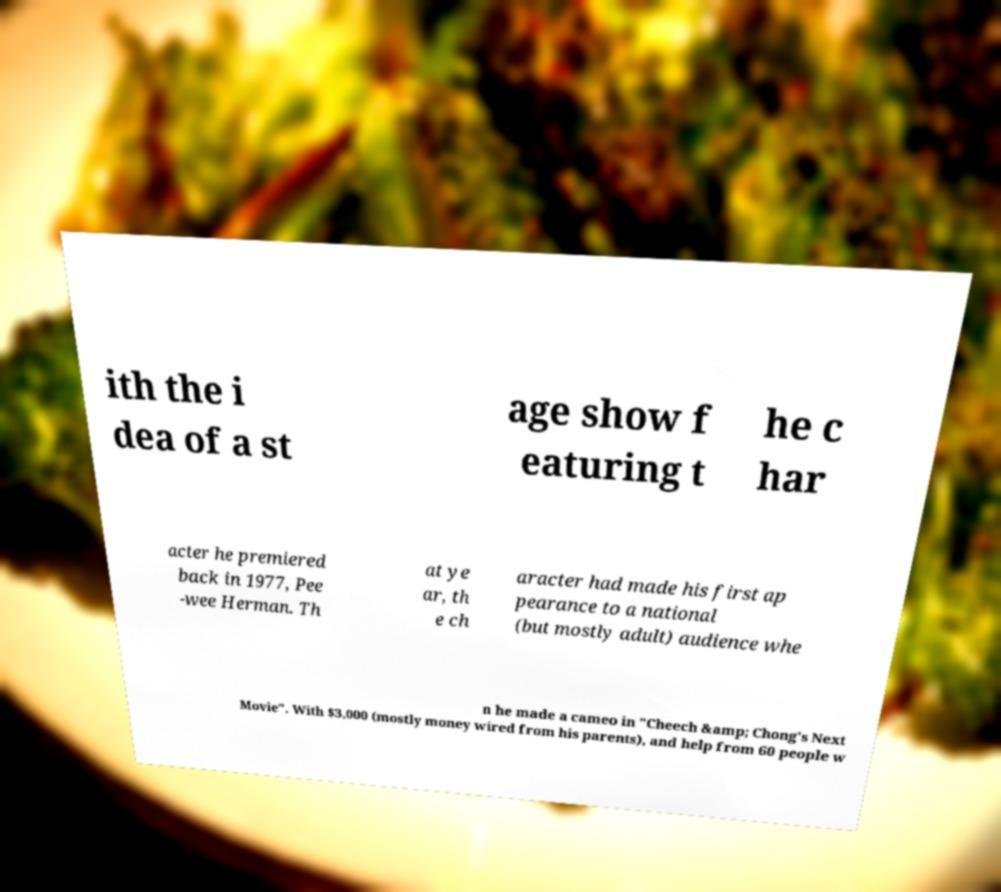There's text embedded in this image that I need extracted. Can you transcribe it verbatim? ith the i dea of a st age show f eaturing t he c har acter he premiered back in 1977, Pee -wee Herman. Th at ye ar, th e ch aracter had made his first ap pearance to a national (but mostly adult) audience whe n he made a cameo in "Cheech &amp; Chong's Next Movie". With $3,000 (mostly money wired from his parents), and help from 60 people w 